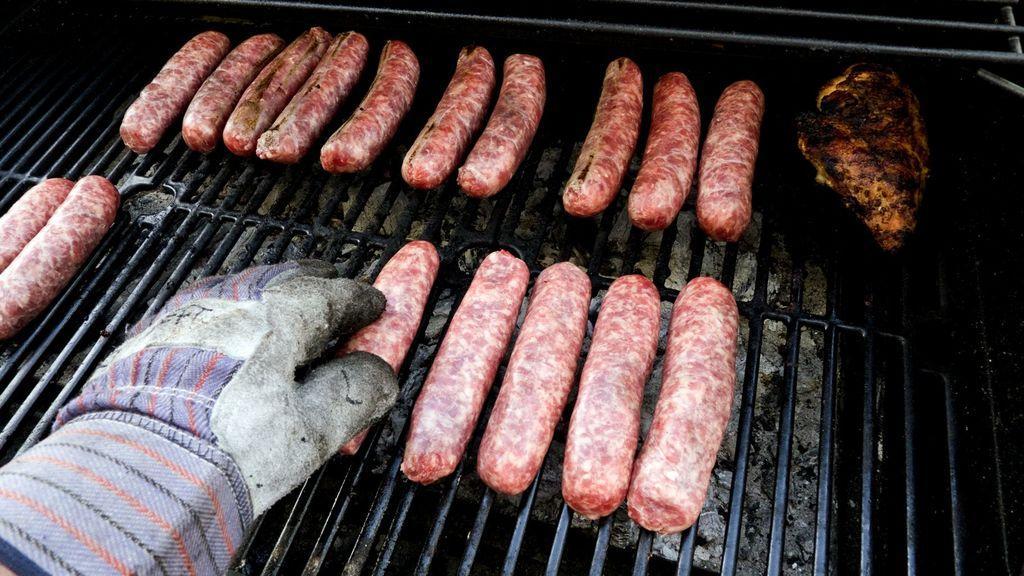Describe this image in one or two sentences. Here in this picture we can see some pieces of sausages present on a grill stand and we can also see a person's hand with glove on it. 